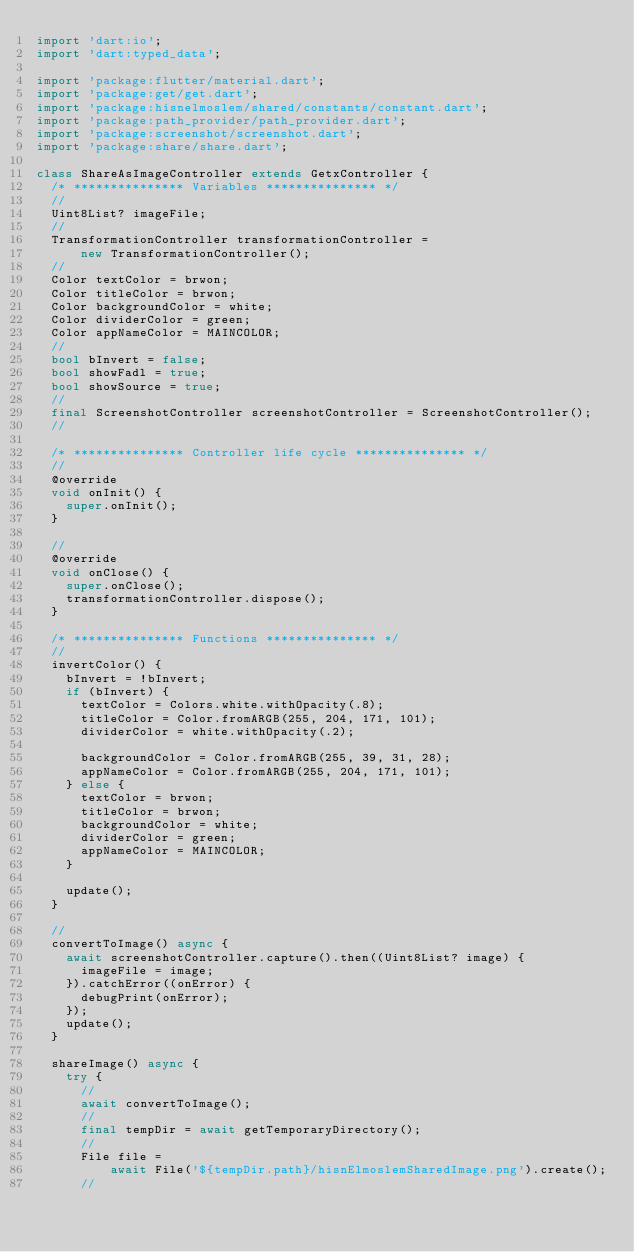<code> <loc_0><loc_0><loc_500><loc_500><_Dart_>import 'dart:io';
import 'dart:typed_data';

import 'package:flutter/material.dart';
import 'package:get/get.dart';
import 'package:hisnelmoslem/shared/constants/constant.dart';
import 'package:path_provider/path_provider.dart';
import 'package:screenshot/screenshot.dart';
import 'package:share/share.dart';

class ShareAsImageController extends GetxController {
  /* *************** Variables *************** */
  //
  Uint8List? imageFile;
  //
  TransformationController transformationController =
      new TransformationController();
  //
  Color textColor = brwon;
  Color titleColor = brwon;
  Color backgroundColor = white;
  Color dividerColor = green;
  Color appNameColor = MAINCOLOR;
  //
  bool bInvert = false;
  bool showFadl = true;
  bool showSource = true;
  //
  final ScreenshotController screenshotController = ScreenshotController();
  //

  /* *************** Controller life cycle *************** */
  //
  @override
  void onInit() {
    super.onInit();
  }

  //
  @override
  void onClose() {
    super.onClose();
    transformationController.dispose();
  }

  /* *************** Functions *************** */
  //
  invertColor() {
    bInvert = !bInvert;
    if (bInvert) {
      textColor = Colors.white.withOpacity(.8);
      titleColor = Color.fromARGB(255, 204, 171, 101);
      dividerColor = white.withOpacity(.2);

      backgroundColor = Color.fromARGB(255, 39, 31, 28);
      appNameColor = Color.fromARGB(255, 204, 171, 101);
    } else {
      textColor = brwon;
      titleColor = brwon;
      backgroundColor = white;
      dividerColor = green;
      appNameColor = MAINCOLOR;
    }

    update();
  }

  //
  convertToImage() async {
    await screenshotController.capture().then((Uint8List? image) {
      imageFile = image;
    }).catchError((onError) {
      debugPrint(onError);
    });
    update();
  }

  shareImage() async {
    try {
      //
      await convertToImage();
      //
      final tempDir = await getTemporaryDirectory();
      //
      File file =
          await File('${tempDir.path}/hisnElmoslemSharedImage.png').create();
      //</code> 